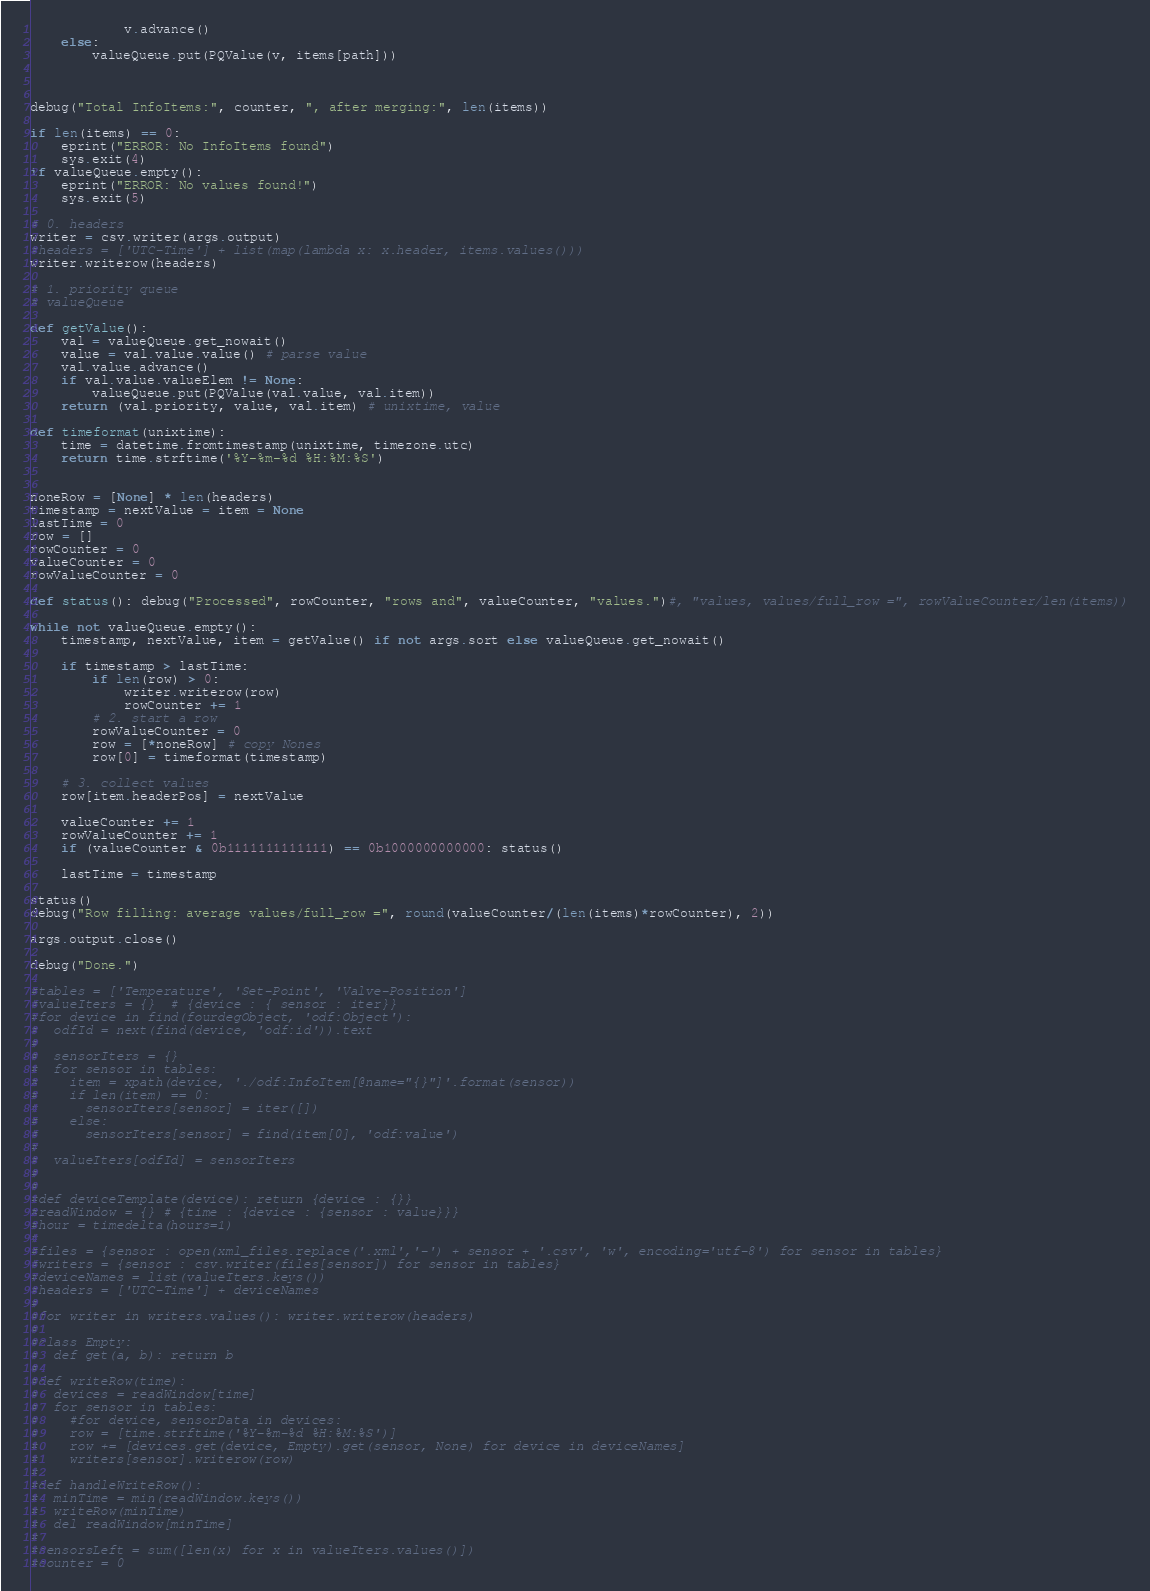<code> <loc_0><loc_0><loc_500><loc_500><_Python_>            v.advance()
    else:
        valueQueue.put(PQValue(v, items[path]))



debug("Total InfoItems:", counter, ", after merging:", len(items))

if len(items) == 0:
    eprint("ERROR: No InfoItems found")
    sys.exit(4)
if valueQueue.empty():
    eprint("ERROR: No values found!")
    sys.exit(5)

# 0. headers
writer = csv.writer(args.output)
#headers = ['UTC-Time'] + list(map(lambda x: x.header, items.values()))
writer.writerow(headers)

# 1. priority queue
# valueQueue

def getValue():
    val = valueQueue.get_nowait()
    value = val.value.value() # parse value
    val.value.advance()
    if val.value.valueElem != None:
        valueQueue.put(PQValue(val.value, val.item))
    return (val.priority, value, val.item) # unixtime, value

def timeformat(unixtime):
    time = datetime.fromtimestamp(unixtime, timezone.utc)
    return time.strftime('%Y-%m-%d %H:%M:%S')


noneRow = [None] * len(headers)
timestamp = nextValue = item = None
lastTime = 0
row = []
rowCounter = 0
valueCounter = 0
rowValueCounter = 0

def status(): debug("Processed", rowCounter, "rows and", valueCounter, "values.")#, "values, values/full_row =", rowValueCounter/len(items))

while not valueQueue.empty():
    timestamp, nextValue, item = getValue() if not args.sort else valueQueue.get_nowait()

    if timestamp > lastTime:
        if len(row) > 0:
            writer.writerow(row)
            rowCounter += 1
        # 2. start a row
        rowValueCounter = 0
        row = [*noneRow] # copy Nones
        row[0] = timeformat(timestamp)

    # 3. collect values
    row[item.headerPos] = nextValue

    valueCounter += 1
    rowValueCounter += 1
    if (valueCounter & 0b1111111111111) == 0b1000000000000: status()

    lastTime = timestamp

status()
debug("Row filling: average values/full_row =", round(valueCounter/(len(items)*rowCounter), 2))

args.output.close()

debug("Done.")

#tables = ['Temperature', 'Set-Point', 'Valve-Position']
#valueIters = {}  # {device : { sensor : iter}}
#for device in find(fourdegObject, 'odf:Object'):
#  odfId = next(find(device, 'odf:id')).text
#
#  sensorIters = {}
#  for sensor in tables:
#    item = xpath(device, './odf:InfoItem[@name="{}"]'.format(sensor))
#    if len(item) == 0:
#      sensorIters[sensor] = iter([])
#    else:
#      sensorIters[sensor] = find(item[0], 'odf:value')
#
#  valueIters[odfId] = sensorIters
#
#
#def deviceTemplate(device): return {device : {}}
#readWindow = {} # {time : {device : {sensor : value}}}
#hour = timedelta(hours=1)
#
#files = {sensor : open(xml_files.replace('.xml','-') + sensor + '.csv', 'w', encoding='utf-8') for sensor in tables}
#writers = {sensor : csv.writer(files[sensor]) for sensor in tables}
#deviceNames = list(valueIters.keys())
#headers = ['UTC-Time'] + deviceNames
#
#for writer in writers.values(): writer.writerow(headers)
#
#class Empty:
#  def get(a, b): return b
#
#def writeRow(time):
#  devices = readWindow[time]
#  for sensor in tables:
#    #for device, sensorData in devices:
#    row = [time.strftime('%Y-%m-%d %H:%M:%S')]
#    row += [devices.get(device, Empty).get(sensor, None) for device in deviceNames]
#    writers[sensor].writerow(row)
#    
#def handleWriteRow():
#  minTime = min(readWindow.keys())
#  writeRow(minTime)
#  del readWindow[minTime]
#  
#sensorsLeft = sum([len(x) for x in valueIters.values()])
#counter = 0</code> 